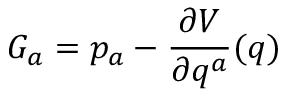Convert formula to latex. <formula><loc_0><loc_0><loc_500><loc_500>G _ { a } = p _ { a } - \frac { \partial V } { \partial q ^ { a } } ( q )</formula> 